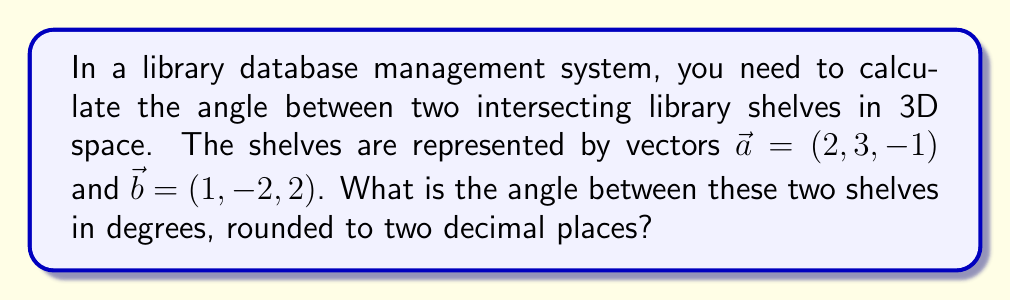Provide a solution to this math problem. To find the angle between two vectors in 3D space, we can use the dot product formula:

$$\cos \theta = \frac{\vec{a} \cdot \vec{b}}{|\vec{a}||\vec{b}|}$$

Where $\theta$ is the angle between the vectors, $\vec{a} \cdot \vec{b}$ is the dot product, and $|\vec{a}|$ and $|\vec{b}|$ are the magnitudes of the vectors.

Step 1: Calculate the dot product $\vec{a} \cdot \vec{b}$
$$\vec{a} \cdot \vec{b} = (2)(1) + (3)(-2) + (-1)(2) = 2 - 6 - 2 = -6$$

Step 2: Calculate the magnitudes of $\vec{a}$ and $\vec{b}$
$$|\vec{a}| = \sqrt{2^2 + 3^2 + (-1)^2} = \sqrt{4 + 9 + 1} = \sqrt{14}$$
$$|\vec{b}| = \sqrt{1^2 + (-2)^2 + 2^2} = \sqrt{1 + 4 + 4} = 3$$

Step 3: Apply the dot product formula
$$\cos \theta = \frac{-6}{\sqrt{14} \cdot 3} = \frac{-6}{3\sqrt{14}}$$

Step 4: Take the inverse cosine (arccos) of both sides
$$\theta = \arccos\left(\frac{-6}{3\sqrt{14}}\right)$$

Step 5: Convert to degrees and round to two decimal places
$$\theta \approx 116.57°$$
Answer: 116.57° 